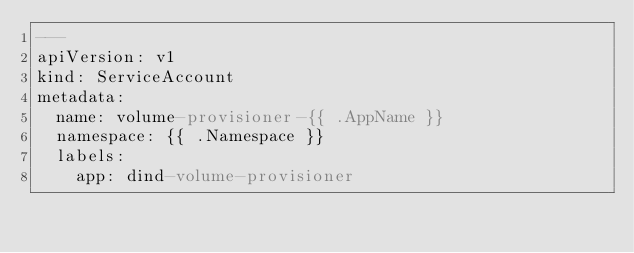Convert code to text. <code><loc_0><loc_0><loc_500><loc_500><_YAML_>---
apiVersion: v1
kind: ServiceAccount
metadata:
  name: volume-provisioner-{{ .AppName }}
  namespace: {{ .Namespace }}
  labels:
    app: dind-volume-provisioner
</code> 